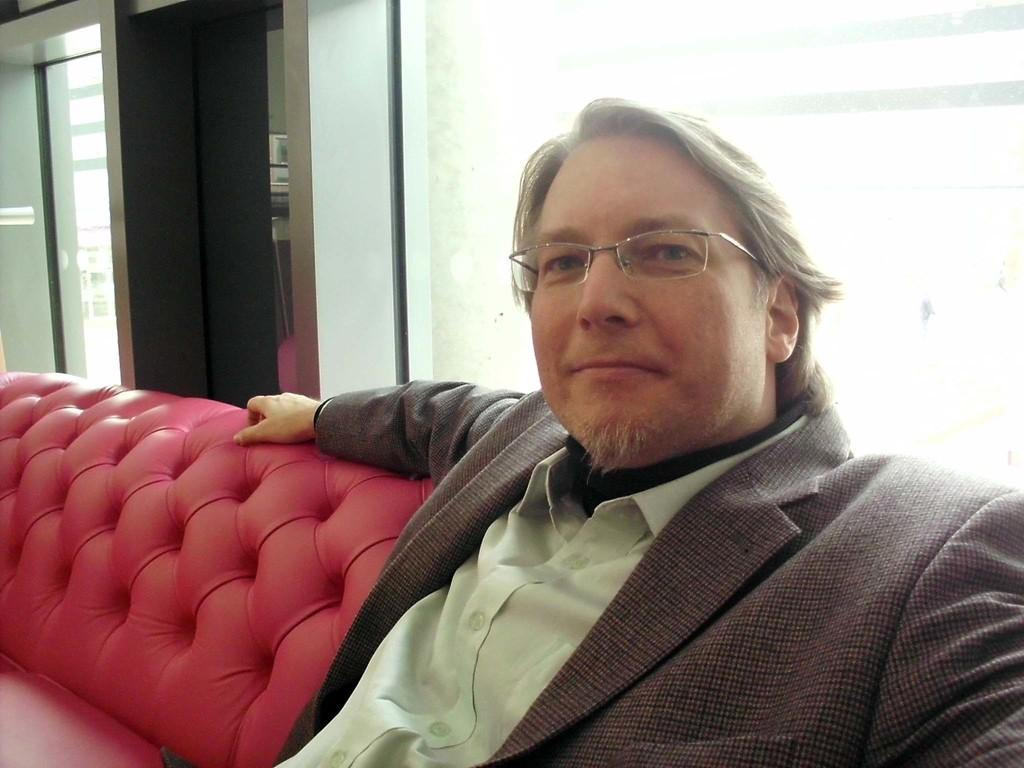What color is the shirt worn by the person in the image? The person in the image is wearing a green shirt. What other clothing item is the person wearing? The person is also wearing an ash-colored coat. What type of walls can be seen in the background of the image? There are glass walls visible in the background of the image. What type of machine is the person using to enhance their thumb in the image? There is no machine or thumb enhancement visible in the image. 